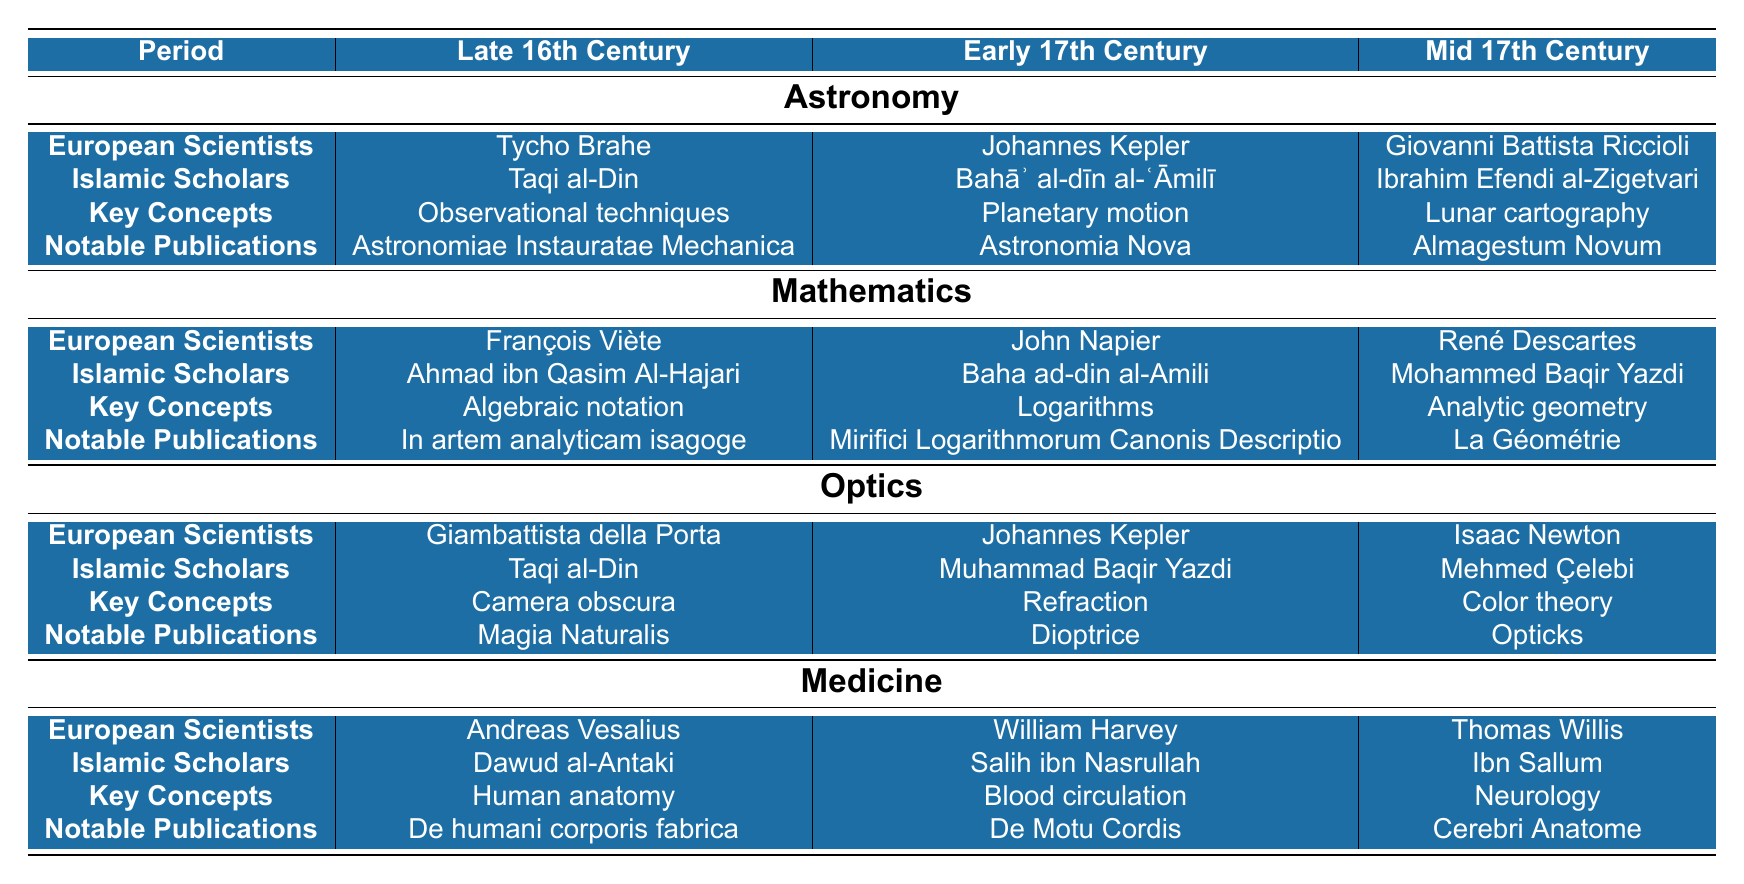What scientific field did Johannes Kepler contribute to in the Early 17th Century? According to the table, Johannes Kepler is listed under the Early 17th Century in the Astronomy field, indicating that this is the field he contributed to during that time.
Answer: Astronomy Which Islamic scholar is associated with the concept of logarithms in the Early 17th Century? The table shows that in the Early 17th Century, the Islamic scholar associated with the concept of logarithms is Baha ad-din al-Amili, who is listed under the Mathematics field.
Answer: Baha ad-din al-Amili Did Isaac Newton publish work on blood circulation? Checking the table, Isaac Newton is listed under the Mid 17th Century in the Optics field; there is no mention of blood circulation being associated with him. Instead, William Harvey is listed for that topic. Therefore, the statement is false.
Answer: No What key concepts were exchanged in the field of optics during the Mid 17th Century? The table specifies that in the Mid 17th Century, the key concept exchanged in optics was color theory, as associated with Isaac Newton.
Answer: Color theory Which European scientist, noted for work in medicine during the Late 16th Century, made significant contributions to human anatomy? The table indicates that Andreas Vesalius is noted as the European scientist who focused on human anatomy in the Late 16th Century under the Medicine field.
Answer: Andreas Vesalius List all European scientists observed in the field of Mathematics across the three centuries. By reviewing the table, the European scientists listed in Mathematics are François Viète in the Late 16th Century, John Napier in the Early 17th Century, and René Descartes in the Mid 17th Century. Thus, the list includes all three names.
Answer: François Viète, John Napier, René Descartes What notable publication is associated with Taqi al-Din in the field of Astronomy during the Late 16th Century? Referring to the table, Taqi al-Din's notable publication in the field of Astronomy during this period is "Astronomiae Instauratae Mechanica."
Answer: Astronomiae Instauratae Mechanica Compare the key concepts exchanged in Mathematics during the Late 16th Century and the Mid 17th Century. The table shows that in Mathematics, the key concept exchanged in the Late 16th Century was algebraic notation, while it was analytic geometry in the Mid 17th Century. This shows a progression from fundamental notation to a broader geometry concept.
Answer: Algebraic notation vs. Analytic geometry What can be inferred about the relationship between Islamic scholars and European scientists in the field of Optics? The table indicates active participation and exchange of knowledge between Islamic scholars and European scientists in the field of Optics, as both groups contributed key concepts and publications throughout the periods listed. This suggests a collaborative relationship in scientific advancement.
Answer: Collaborative relationship Who was noted for the publication "La Géométrie" and what was its significance? The publication "La Géométrie" is associated with René Descartes in the Mid 17th Century according to the table. Its significance lies in the development of analytic geometry, marking an important evolution of mathematical thought in this period.
Answer: René Descartes; it signifies the development of analytic geometry 